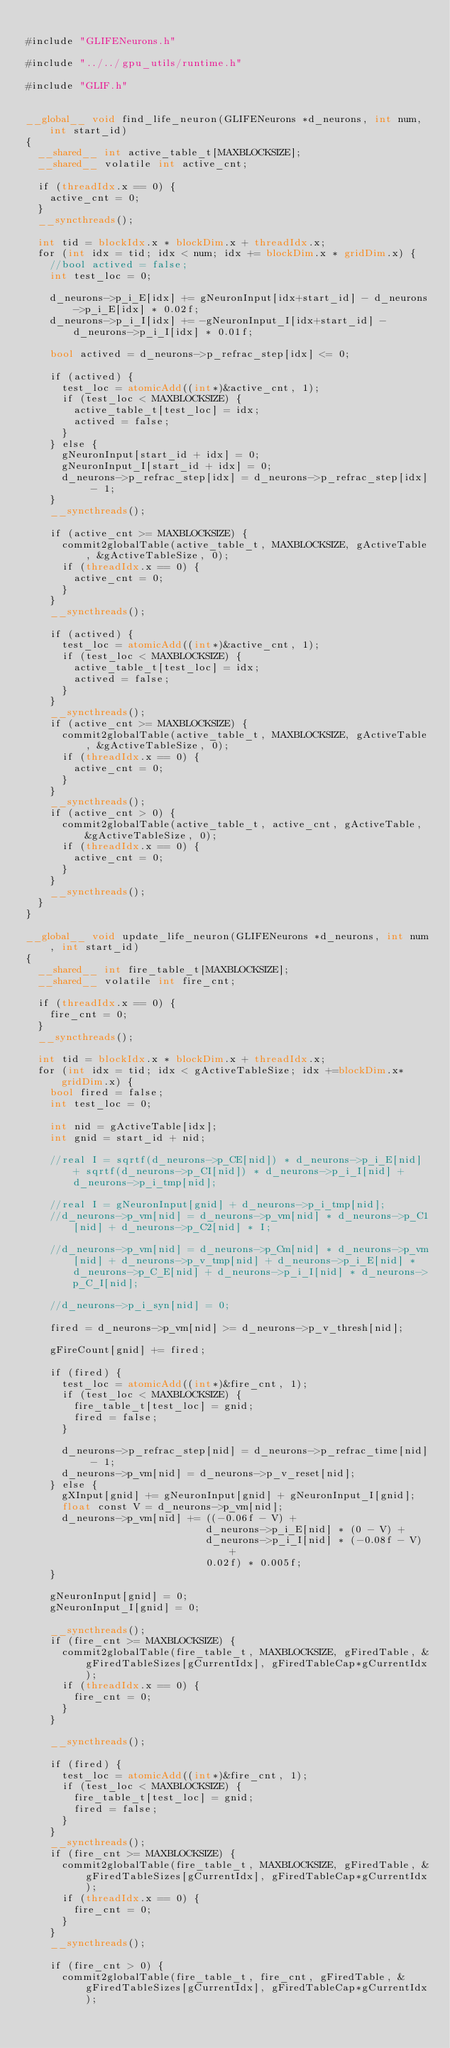<code> <loc_0><loc_0><loc_500><loc_500><_Cuda_>
#include "GLIFENeurons.h"

#include "../../gpu_utils/runtime.h"

#include "GLIF.h"


__global__ void find_life_neuron(GLIFENeurons *d_neurons, int num, int start_id)
{
	__shared__ int active_table_t[MAXBLOCKSIZE];
	__shared__ volatile int active_cnt;

	if (threadIdx.x == 0) {
		active_cnt = 0;
	}
	__syncthreads();

	int tid = blockIdx.x * blockDim.x + threadIdx.x;
	for (int idx = tid; idx < num; idx += blockDim.x * gridDim.x) {
		//bool actived = false;
		int test_loc = 0;

		d_neurons->p_i_E[idx] += gNeuronInput[idx+start_id] - d_neurons->p_i_E[idx] * 0.02f;
		d_neurons->p_i_I[idx] += -gNeuronInput_I[idx+start_id] - d_neurons->p_i_I[idx] * 0.01f;

		bool actived = d_neurons->p_refrac_step[idx] <= 0;

		if (actived) {
			test_loc = atomicAdd((int*)&active_cnt, 1);
			if (test_loc < MAXBLOCKSIZE) {
				active_table_t[test_loc] = idx;
				actived = false;
			}
		} else {
			gNeuronInput[start_id + idx] = 0;
			gNeuronInput_I[start_id + idx] = 0;
			d_neurons->p_refrac_step[idx] = d_neurons->p_refrac_step[idx] - 1;
		}
		__syncthreads();

		if (active_cnt >= MAXBLOCKSIZE) {
			commit2globalTable(active_table_t, MAXBLOCKSIZE, gActiveTable, &gActiveTableSize, 0);
			if (threadIdx.x == 0) {
				active_cnt = 0;
			}
		}
		__syncthreads();

		if (actived) {
			test_loc = atomicAdd((int*)&active_cnt, 1);
			if (test_loc < MAXBLOCKSIZE) {
				active_table_t[test_loc] = idx;
				actived = false;
			}
		}
		__syncthreads();
		if (active_cnt >= MAXBLOCKSIZE) {
			commit2globalTable(active_table_t, MAXBLOCKSIZE, gActiveTable, &gActiveTableSize, 0);
			if (threadIdx.x == 0) {
				active_cnt = 0;
			}
		}
		__syncthreads();
		if (active_cnt > 0) {
			commit2globalTable(active_table_t, active_cnt, gActiveTable, &gActiveTableSize, 0);
			if (threadIdx.x == 0) {
				active_cnt = 0;
			}
		}
		__syncthreads();
	}
}

__global__ void update_life_neuron(GLIFENeurons *d_neurons, int num, int start_id)
{
	__shared__ int fire_table_t[MAXBLOCKSIZE];
	__shared__ volatile int fire_cnt;

	if (threadIdx.x == 0) {
		fire_cnt = 0;
	}
	__syncthreads();

	int tid = blockIdx.x * blockDim.x + threadIdx.x;
	for (int idx = tid; idx < gActiveTableSize; idx +=blockDim.x*gridDim.x) {
		bool fired = false;
		int test_loc = 0;

		int nid = gActiveTable[idx];
		int gnid = start_id + nid; 

		//real I = sqrtf(d_neurons->p_CE[nid]) * d_neurons->p_i_E[nid] + sqrtf(d_neurons->p_CI[nid]) * d_neurons->p_i_I[nid] + d_neurons->p_i_tmp[nid];

		//real I = gNeuronInput[gnid] + d_neurons->p_i_tmp[nid];
		//d_neurons->p_vm[nid] = d_neurons->p_vm[nid] * d_neurons->p_C1[nid] + d_neurons->p_C2[nid] * I;

		//d_neurons->p_vm[nid] = d_neurons->p_Cm[nid] * d_neurons->p_vm[nid] + d_neurons->p_v_tmp[nid] + d_neurons->p_i_E[nid] * d_neurons->p_C_E[nid] + d_neurons->p_i_I[nid] * d_neurons->p_C_I[nid];

		//d_neurons->p_i_syn[nid] = 0;

		fired = d_neurons->p_vm[nid] >= d_neurons->p_v_thresh[nid];

		gFireCount[gnid] += fired;

		if (fired) {
			test_loc = atomicAdd((int*)&fire_cnt, 1);
			if (test_loc < MAXBLOCKSIZE) {
				fire_table_t[test_loc] = gnid;
				fired = false;
			}

			d_neurons->p_refrac_step[nid] = d_neurons->p_refrac_time[nid] - 1;
			d_neurons->p_vm[nid] = d_neurons->p_v_reset[nid];
		} else {
			gXInput[gnid] += gNeuronInput[gnid] + gNeuronInput_I[gnid];
			float const V = d_neurons->p_vm[nid];
			d_neurons->p_vm[nid] += ((-0.06f - V) +
			                        d_neurons->p_i_E[nid] * (0 - V) +
			                        d_neurons->p_i_I[nid] * (-0.08f - V) +
			                        0.02f) * 0.005f;
		}

		gNeuronInput[gnid] = 0;
		gNeuronInput_I[gnid] = 0;

		__syncthreads();
		if (fire_cnt >= MAXBLOCKSIZE) {
			commit2globalTable(fire_table_t, MAXBLOCKSIZE, gFiredTable, &gFiredTableSizes[gCurrentIdx], gFiredTableCap*gCurrentIdx);
			if (threadIdx.x == 0) {
				fire_cnt = 0;
			}
		}

		__syncthreads();

		if (fired) {
			test_loc = atomicAdd((int*)&fire_cnt, 1);
			if (test_loc < MAXBLOCKSIZE) {
				fire_table_t[test_loc] = gnid;
				fired = false;
			}
		}
		__syncthreads();
		if (fire_cnt >= MAXBLOCKSIZE) {
			commit2globalTable(fire_table_t, MAXBLOCKSIZE, gFiredTable, &gFiredTableSizes[gCurrentIdx], gFiredTableCap*gCurrentIdx);
			if (threadIdx.x == 0) {
				fire_cnt = 0;
			}
		}
		__syncthreads();

		if (fire_cnt > 0) {
			commit2globalTable(fire_table_t, fire_cnt, gFiredTable, &gFiredTableSizes[gCurrentIdx], gFiredTableCap*gCurrentIdx);</code> 